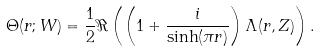Convert formula to latex. <formula><loc_0><loc_0><loc_500><loc_500>\Theta ( r ; W ) = \frac { 1 } { 2 } \Re \left ( \left ( 1 + \frac { i } { \sinh ( \pi r ) } \right ) \Lambda ( r , Z ) \right ) .</formula> 